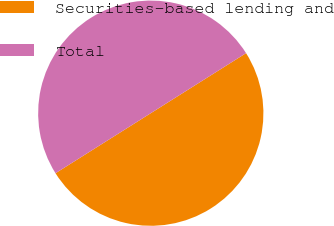<chart> <loc_0><loc_0><loc_500><loc_500><pie_chart><fcel>Securities-based lending and<fcel>Total<nl><fcel>50.0%<fcel>50.0%<nl></chart> 